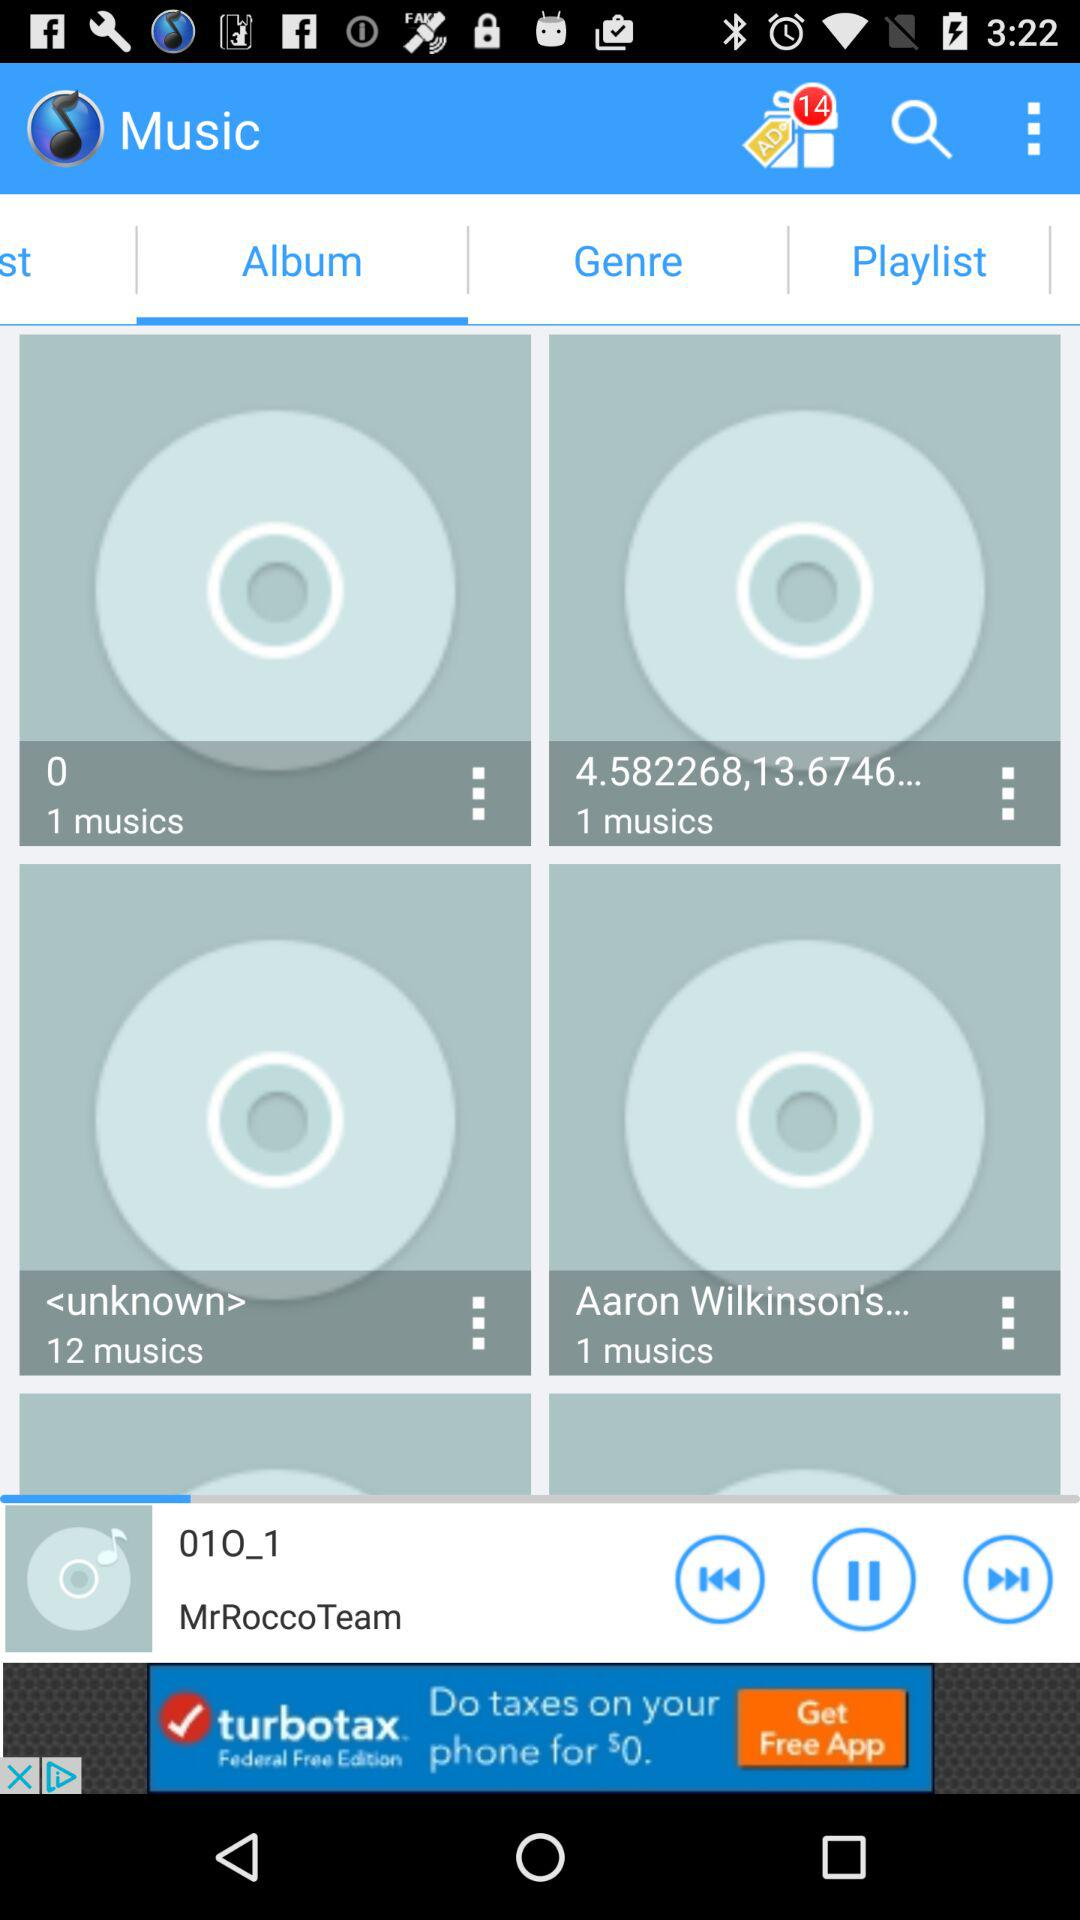What album has the most music? The album that has the most music is "unknown". 